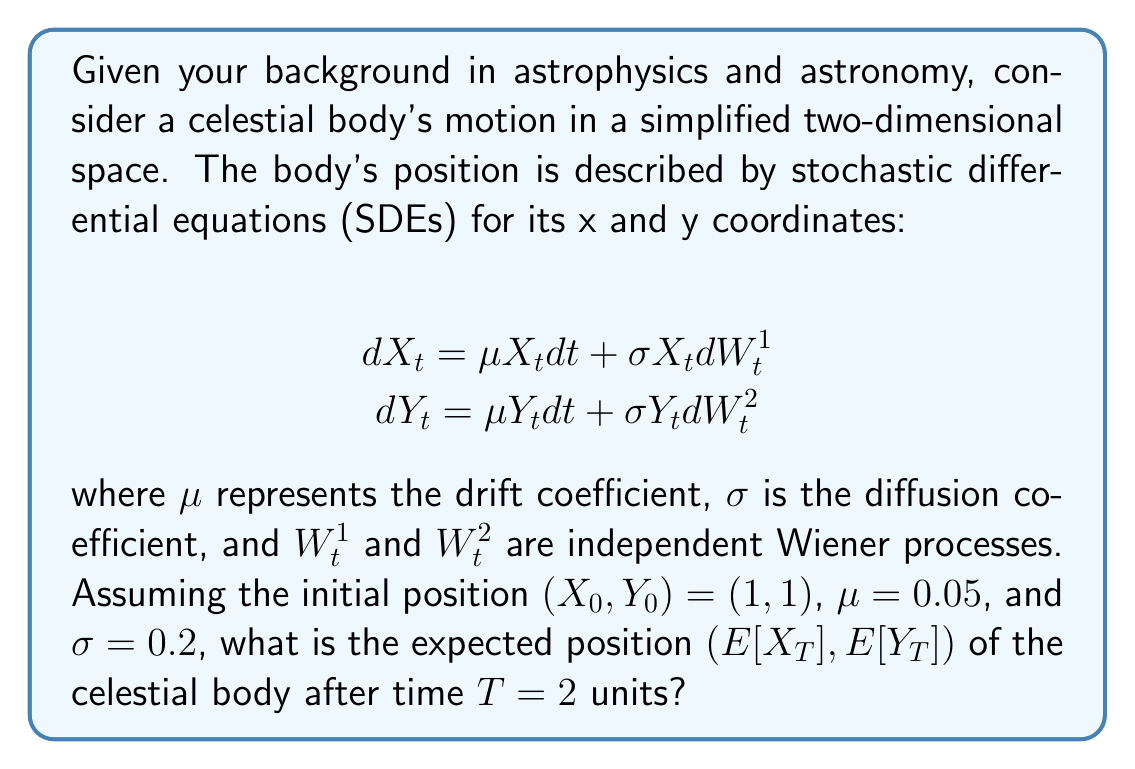Solve this math problem. To solve this problem, we need to understand the properties of geometric Brownian motion, which is described by the given SDEs. The solution to these SDEs is known and follows a log-normal distribution.

For a general SDE of the form:

$$dS_t = \mu S_t dt + \sigma S_t dW_t$$

The expected value at time $T$ is given by:

$$E[S_T] = S_0 e^{\mu T}$$

In our case, both $X_t$ and $Y_t$ follow the same type of SDE with identical parameters. Therefore, we can use this formula for both coordinates.

For the x-coordinate:
$$E[X_T] = X_0 e^{\mu T} = 1 \cdot e^{0.05 \cdot 2} = e^{0.1}$$

For the y-coordinate:
$$E[Y_T] = Y_0 e^{\mu T} = 1 \cdot e^{0.05 \cdot 2} = e^{0.1}$$

To calculate the final value, we need to evaluate $e^{0.1}$:

$$e^{0.1} \approx 1.1052$$

Therefore, the expected position after time $T = 2$ is approximately (1.1052, 1.1052).

Note that the diffusion coefficient $\sigma$ does not appear in the expectation formula. This is because the expectation of the stochastic term (involving the Wiener process) is zero. However, $\sigma$ would affect the variance of the position, which we're not asked to calculate in this problem.
Answer: The expected position of the celestial body after time $T = 2$ is $(E[X_T], E[Y_T]) \approx (1.1052, 1.1052)$. 